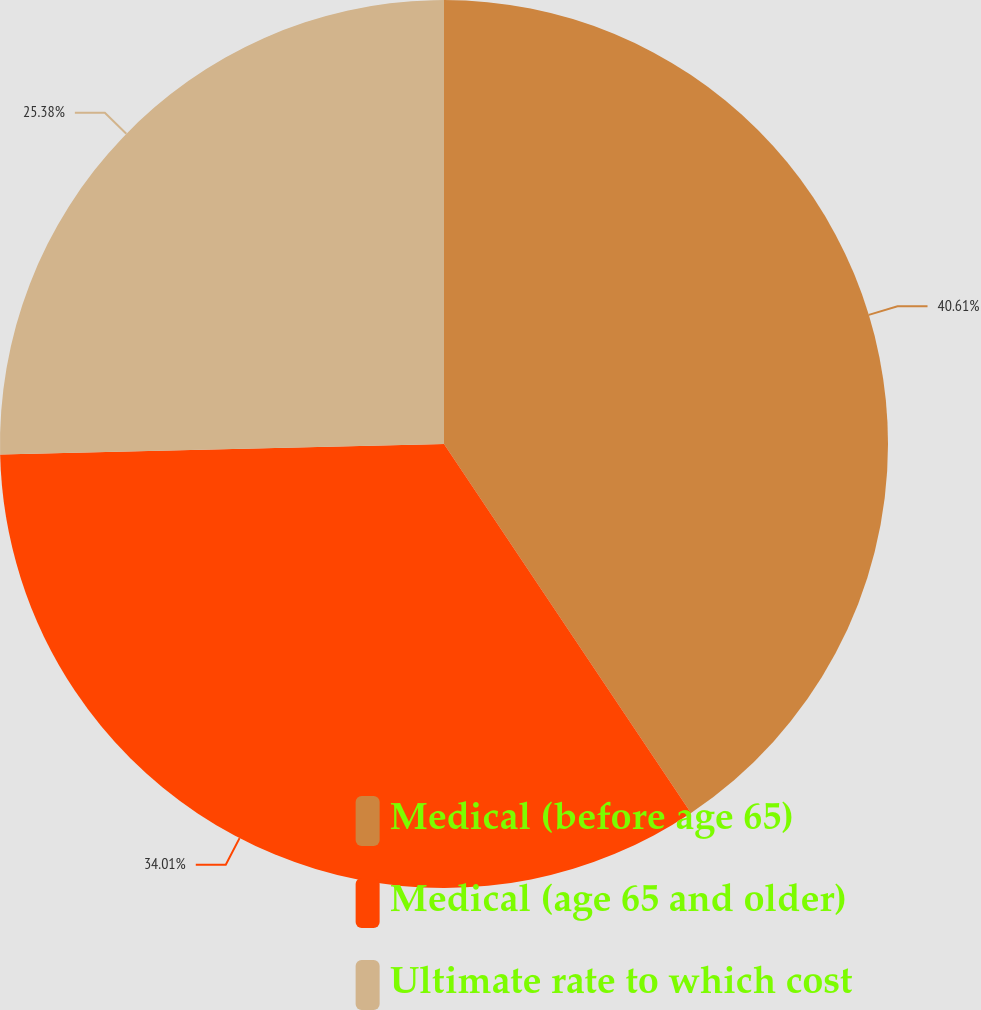Convert chart. <chart><loc_0><loc_0><loc_500><loc_500><pie_chart><fcel>Medical (before age 65)<fcel>Medical (age 65 and older)<fcel>Ultimate rate to which cost<nl><fcel>40.61%<fcel>34.01%<fcel>25.38%<nl></chart> 